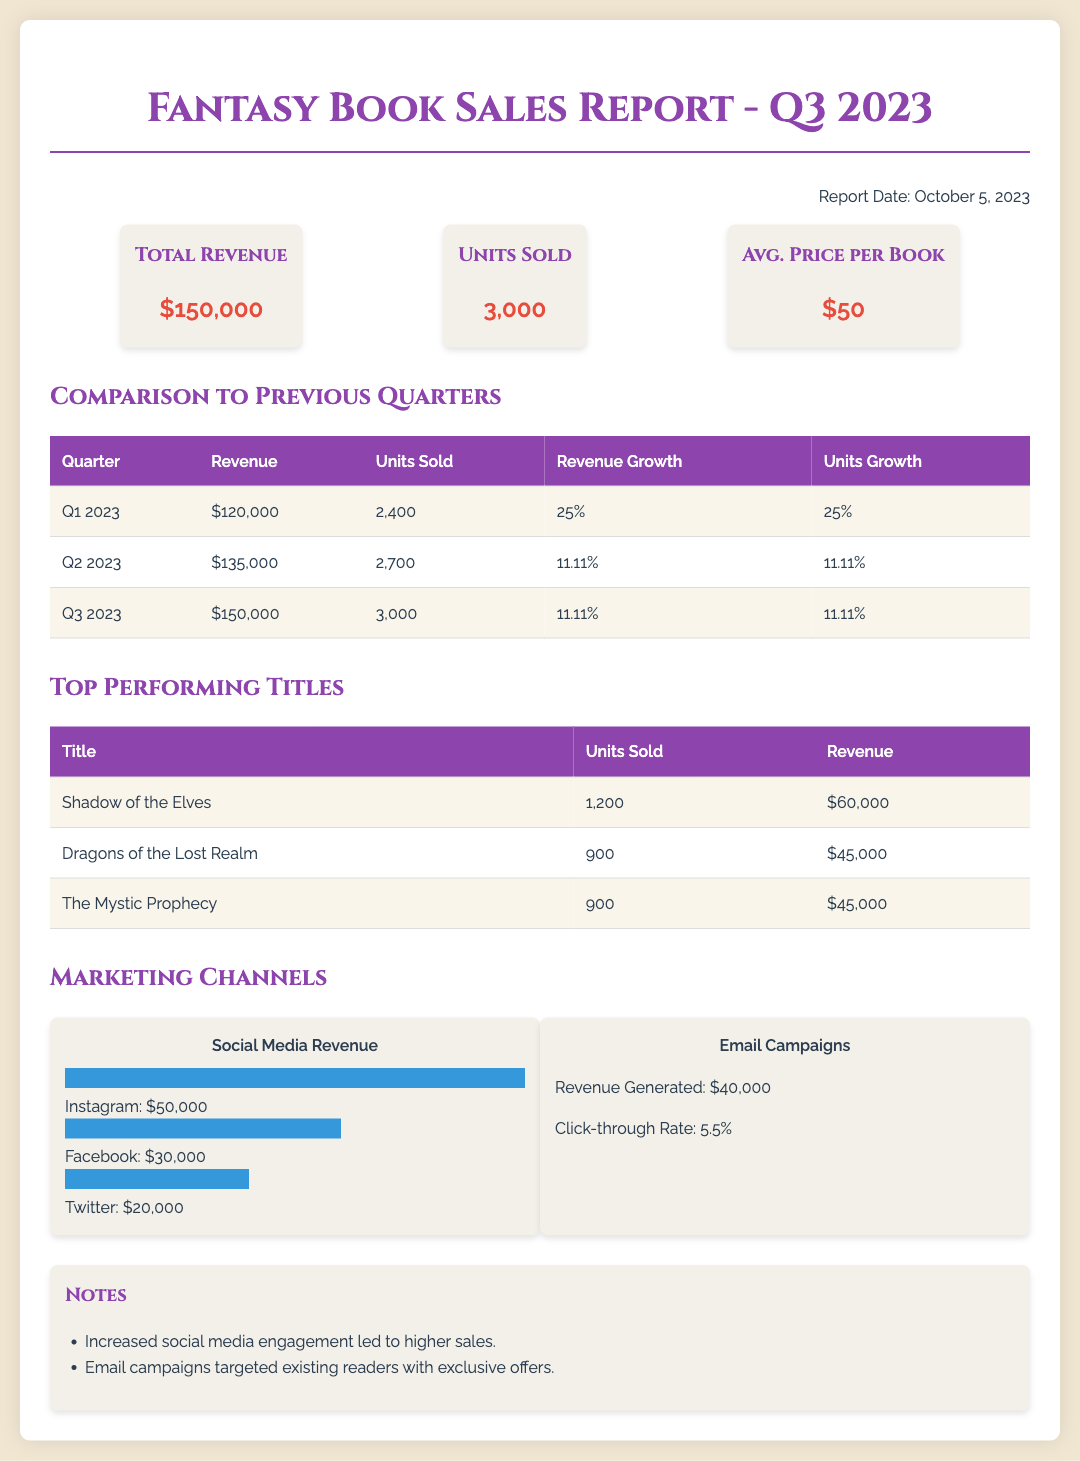What is the total revenue? The total revenue for Q3 2023 is stated clearly in the document as $150,000.
Answer: $150,000 How many units were sold in Q3 2023? The document specifies that a total of 3,000 units were sold in Q3 2023.
Answer: 3,000 What was the average price per book in Q3 2023? The average price per book is directly mentioned in the overview section as $50.
Answer: $50 What is the revenue growth from Q2 2023 to Q3 2023? The document indicates a revenue growth percentage of 11.11% from Q2 to Q3 2023.
Answer: 11.11% Which title sold the most units in Q3 2023? The title that sold the most units, as per the top-performing titles section, is "Shadow of the Elves" with 1,200 units sold.
Answer: Shadow of the Elves How much revenue was generated from social media? The total revenue generated from social media, as shown in the marketing channels section, is $100,000 ($50,000 from Instagram, $30,000 from Facebook, and $20,000 from Twitter).
Answer: $100,000 What was the click-through rate for email campaigns? The document reports that the click-through rate for email campaigns was 5.5%.
Answer: 5.5% How many units were sold in Q1 2023? The document provides the unit sales for Q1 2023, which is 2,400 units sold.
Answer: 2,400 What percentage of revenue growth occurred from Q1 2023 to Q2 2023? The document states that from Q1 2023 to Q2 2023, the revenue growth percentage was 11.11%.
Answer: 11.11% 